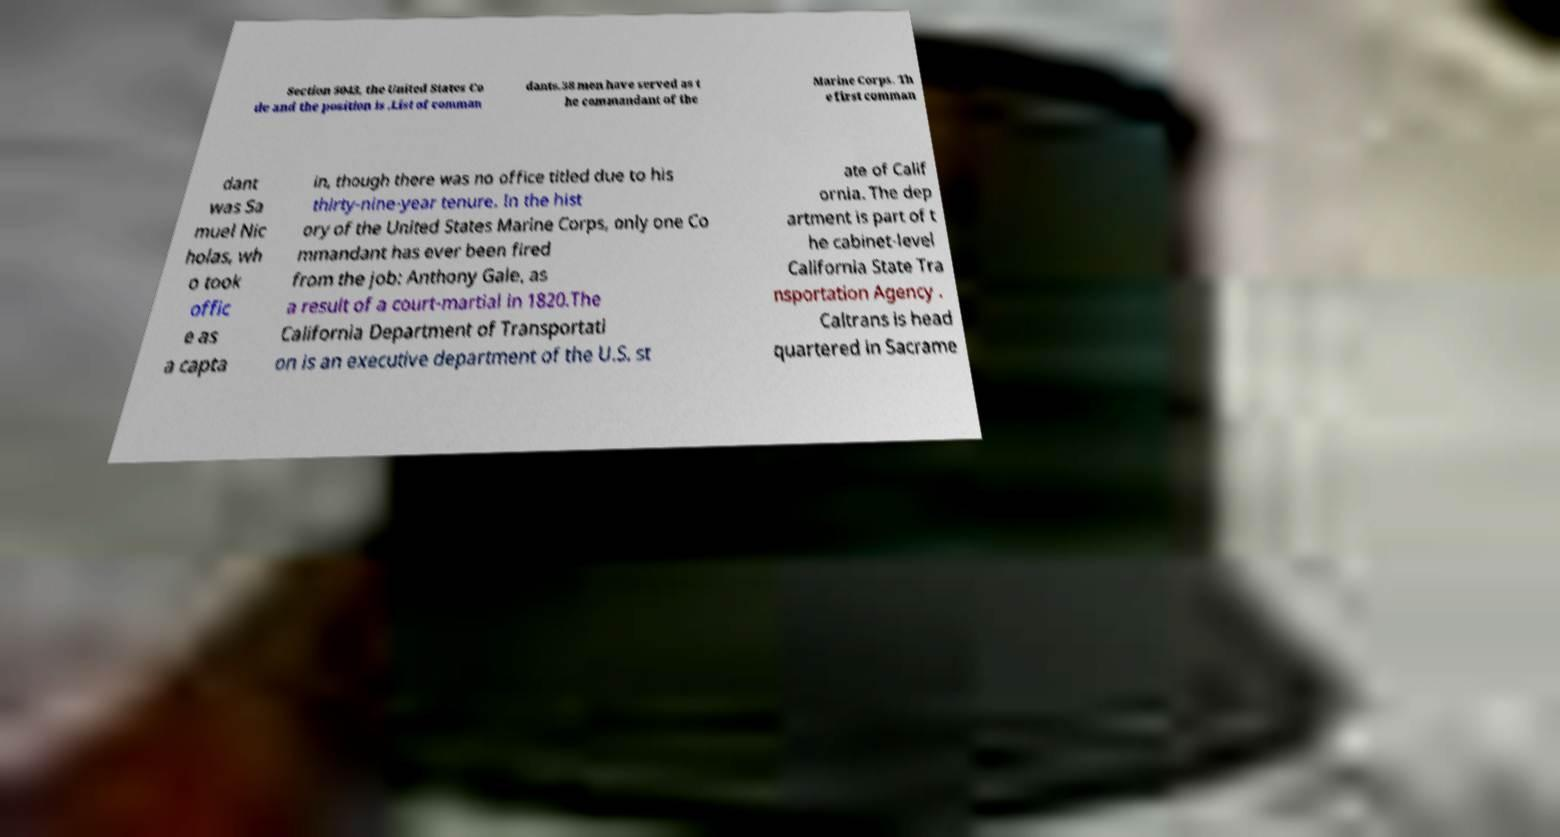Can you read and provide the text displayed in the image?This photo seems to have some interesting text. Can you extract and type it out for me? Section 5043, the United States Co de and the position is .List of comman dants.38 men have served as t he commandant of the Marine Corps. Th e first comman dant was Sa muel Nic holas, wh o took offic e as a capta in, though there was no office titled due to his thirty-nine-year tenure. In the hist ory of the United States Marine Corps, only one Co mmandant has ever been fired from the job: Anthony Gale, as a result of a court-martial in 1820.The California Department of Transportati on is an executive department of the U.S. st ate of Calif ornia. The dep artment is part of t he cabinet-level California State Tra nsportation Agency . Caltrans is head quartered in Sacrame 